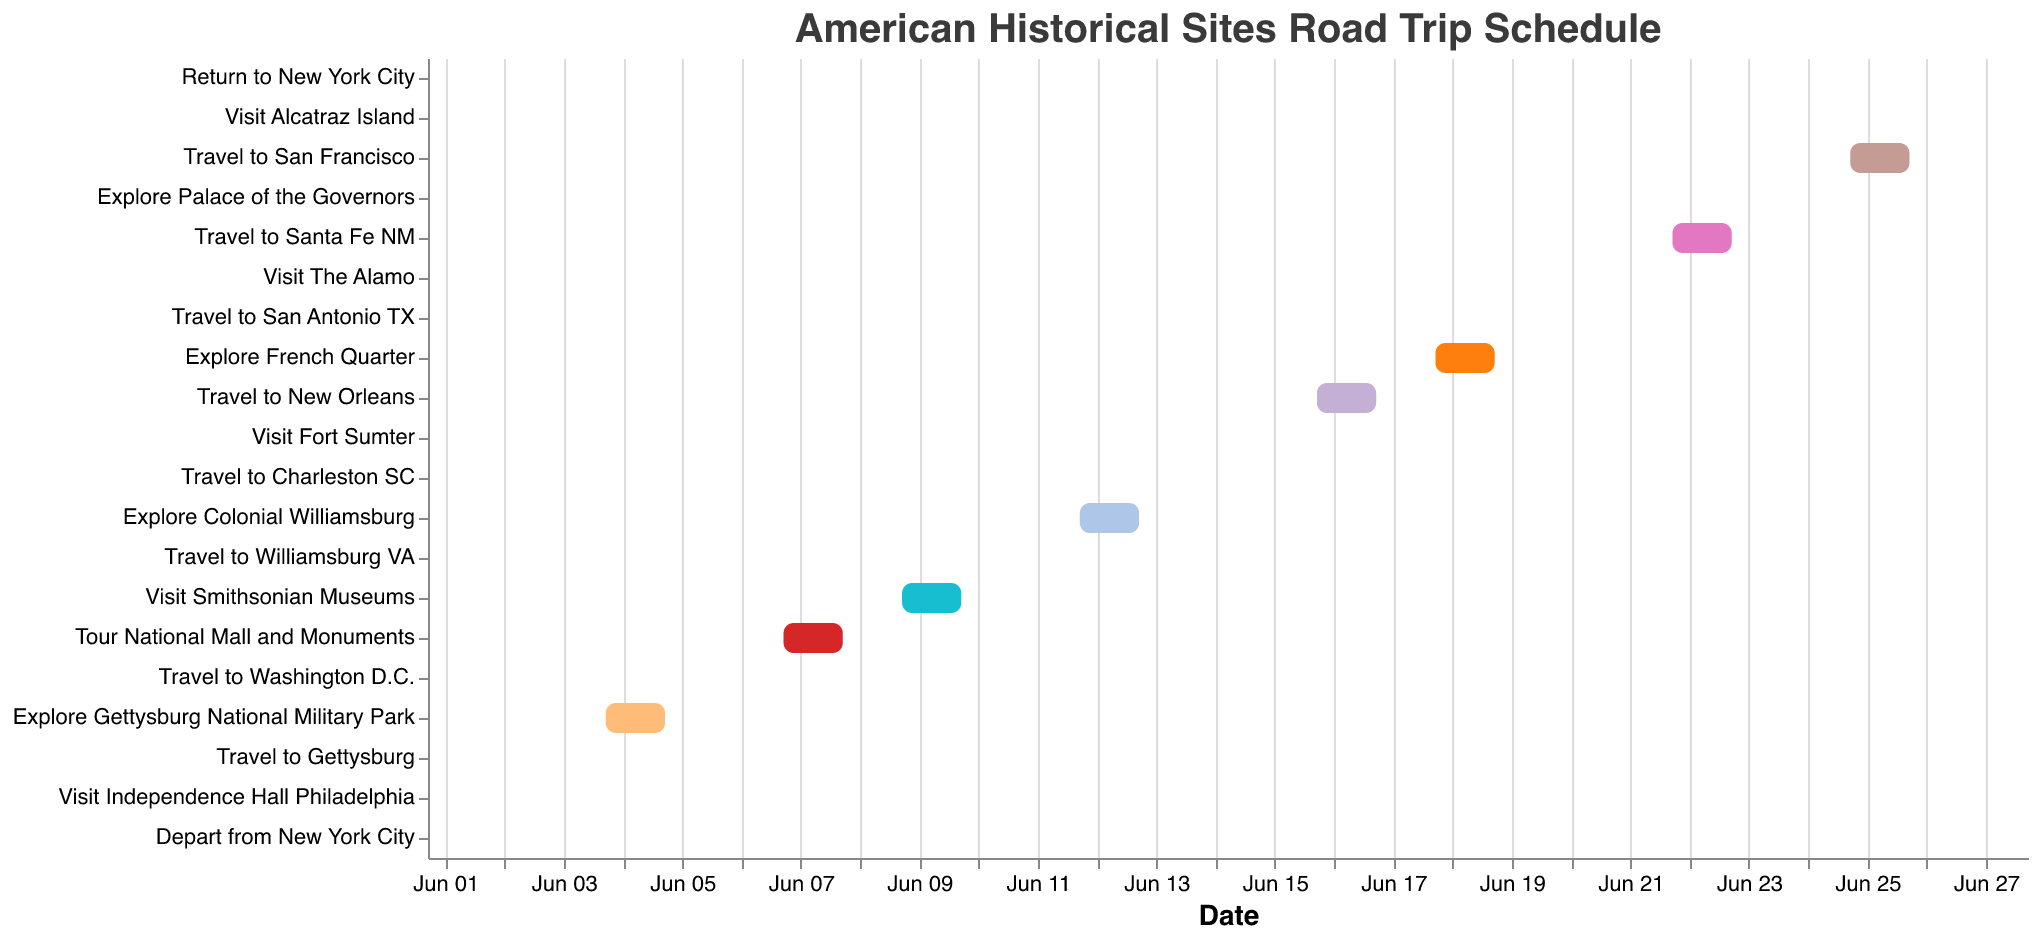What is the title of the figure? The title of the figure is usually written at the top center of the chart. In this case, the title is stated as "American Historical Sites Road Trip Schedule".
Answer: American Historical Sites Road Trip Schedule How long will be the entire road trip from start to finish? The trip starts on June 1, 2023, and ends on June 28, 2023. To calculate the duration, count the days from June 1 to June 28 inclusive.
Answer: 28 days Which historical site is visited immediately after touring the National Mall and Monuments? After the visit to the National Mall and Monuments (June 7-8), the next historical site visited is the Smithsonian Museums on June 9-10.
Answer: Smithsonian Museums How many days are spent in New Orleans? The trip to New Orleans includes a travel period from June 16-17 and then exploring the French Quarter from June 18-19. Therefore, the total days spent in New Orleans is 4 days.
Answer: 4 days Which task has the longest duration? Each bar in the Gantt chart represents the duration of a task. By comparing the lengths of the bars, the longest duration task is "Travel to New Orleans" spanning from June 16-17.
Answer: Travel to New Orleans What is the duration of the stay at Gettysburg National Military Park? Look for the task "Explore Gettysburg National Military Park" on the chart, which spans from June 4 to June 5, totaling 2 days.
Answer: 2 days Which tasks involve traveling to a new location? Tasks that start with the word "Travel" are the ones that involve traveling to a new location. The chart shows several of these: "Travel to Gettysburg", "Travel to Washington D.C.", "Travel to Williamsburg VA", "Travel to Charleston SC", "Travel to New Orleans", "Travel to San Antonio TX", "Travel to Santa Fe NM", "Travel to San Francisco", and "Return to New York City".
Answer: Travel to Gettysburg, Travel to Washington D.C., Travel to Williamsburg VA, Travel to Charleston SC, Travel to New Orleans, Travel to San Antonio TX, Travel to Santa Fe NM, Travel to San Francisco, Return to New York City What is the total number of travel days in the schedule? Identify all the tasks that involve traveling and sum the number of days for each. The chart indicates travel on June 3, 6, 11, 14, 16-17 (2 days), 20, 22-23 (2 days), 25-26 (2 days), and 28. There are 10 travel days in total.
Answer: 10 days During which period is the trip to Williamsburg VA scheduled? Locate the task "Travel to Williamsburg VA" and its associated dates on the chart. The travel date is June 11 and the period includes June 12-13 for exploring.
Answer: June 11-13 